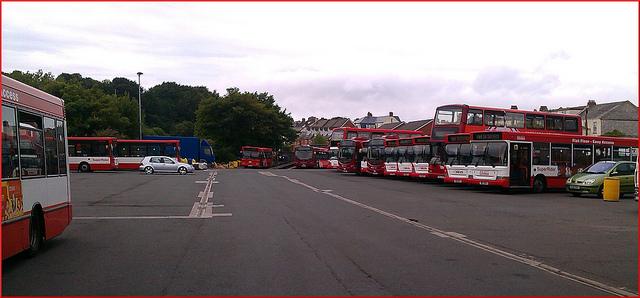What season is it?
Answer briefly. Spring. Where is the bus?
Give a very brief answer. Parking lot. Where are buses parked in the picture?
Quick response, please. Parking lot. What types of vehicles are there?
Short answer required. Buses. What color is the bus?
Write a very short answer. Red. Are there a lot of buses?
Concise answer only. Yes. How many cars are parked?
Be succinct. 2. 